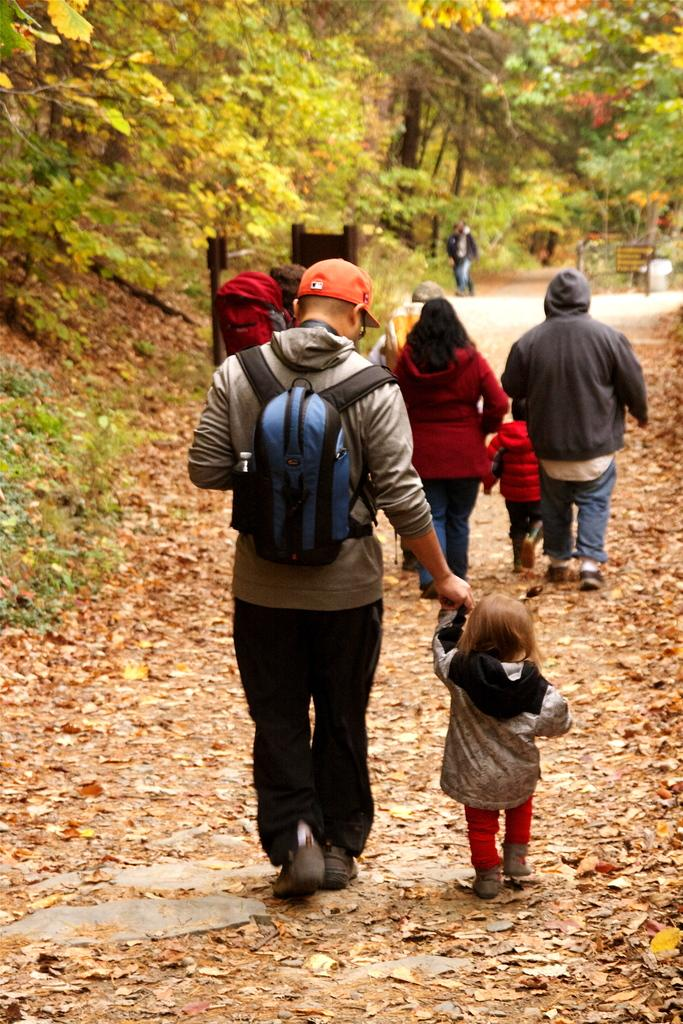What are the persons in the image doing? The persons in the image are walking. Where are the persons walking? The persons are walking on a road. What can be seen in the background of the image? There are trees in the background of the image. What type of destruction can be seen in the image? There is no destruction present in the image; it shows persons walking on a road with trees in the background. 